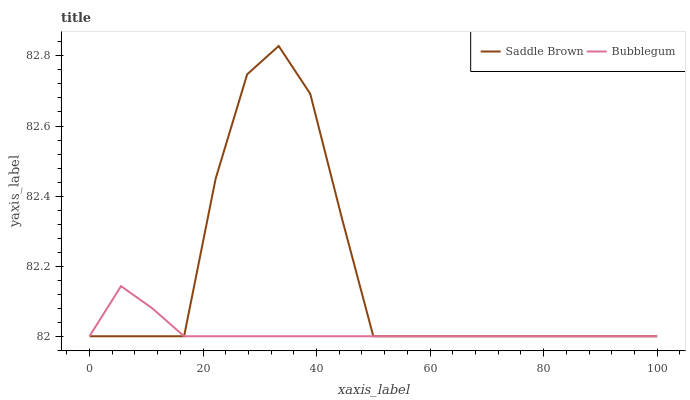Does Bubblegum have the minimum area under the curve?
Answer yes or no. Yes. Does Saddle Brown have the maximum area under the curve?
Answer yes or no. Yes. Does Bubblegum have the maximum area under the curve?
Answer yes or no. No. Is Bubblegum the smoothest?
Answer yes or no. Yes. Is Saddle Brown the roughest?
Answer yes or no. Yes. Is Bubblegum the roughest?
Answer yes or no. No. Does Saddle Brown have the highest value?
Answer yes or no. Yes. Does Bubblegum have the highest value?
Answer yes or no. No. Does Saddle Brown intersect Bubblegum?
Answer yes or no. Yes. Is Saddle Brown less than Bubblegum?
Answer yes or no. No. Is Saddle Brown greater than Bubblegum?
Answer yes or no. No. 